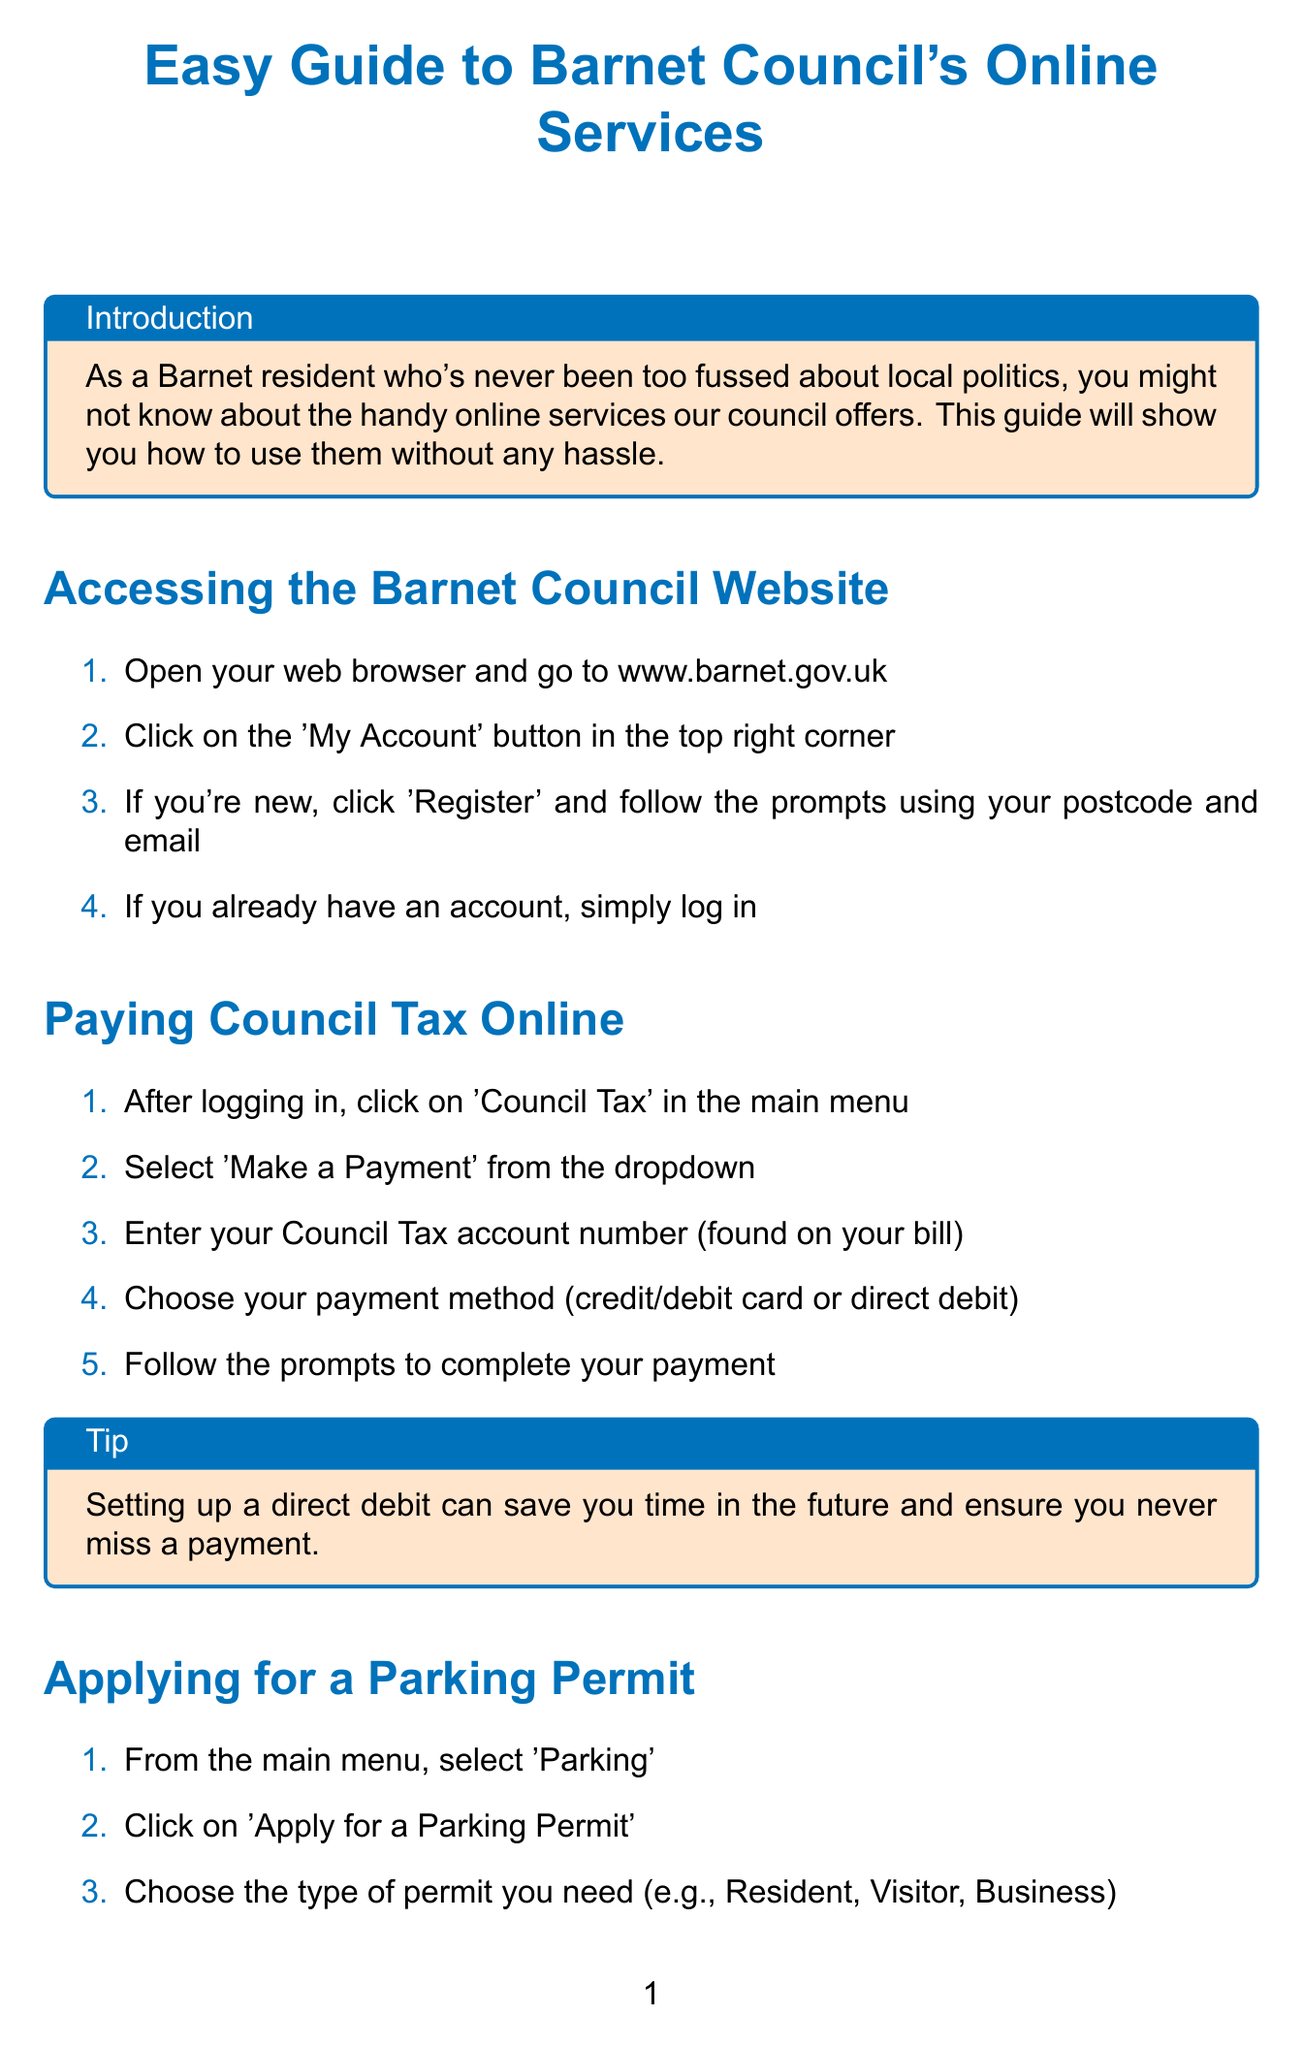What is the title of the document? The title of the document is the main topic presented in a bold format at the beginning.
Answer: Easy Guide to Barnet Council's Online Services How do you access the Barnet Council website? The method for accessing the website is outlined in the instructions provided in the document.
Answer: www.barnet.gov.uk What should you click after logging in to pay council tax? This step is specifically mentioned in the section for paying council tax online.
Answer: Council Tax What is a tip provided when paying council tax? The document offers helpful tips to users on saving time and ensuring payments are made.
Answer: Setting up a direct debit can save you time in the future and ensure you never miss a payment What type of issues can you report using Barnet Council's online services? The document lists specific issues residents can report, highlighting their relevance to council services.
Answer: Problems like fly-tipping or potholes How can you check bin collection dates? The process for checking collection dates is described in a straightforward set of steps.
Answer: From the homepage, click on 'Bins and recycling' What information do you need to apply for a parking permit? The steps outline what information will be required for the application process.
Answer: Vehicle details and address What is the conclusion of the manual? The concluding remarks summarize the purpose and usability of the online services mentioned in the guide.
Answer: Using Barnet Council's online services is straightforward and can save you time What is a useful link provided in the document? The document contains links to resources that assist residents in accessing online services.
Answer: Barnet Council Homepage 